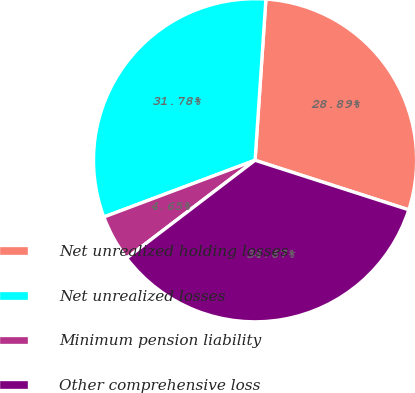Convert chart. <chart><loc_0><loc_0><loc_500><loc_500><pie_chart><fcel>Net unrealized holding losses<fcel>Net unrealized losses<fcel>Minimum pension liability<fcel>Other comprehensive loss<nl><fcel>28.89%<fcel>31.78%<fcel>4.65%<fcel>34.67%<nl></chart> 